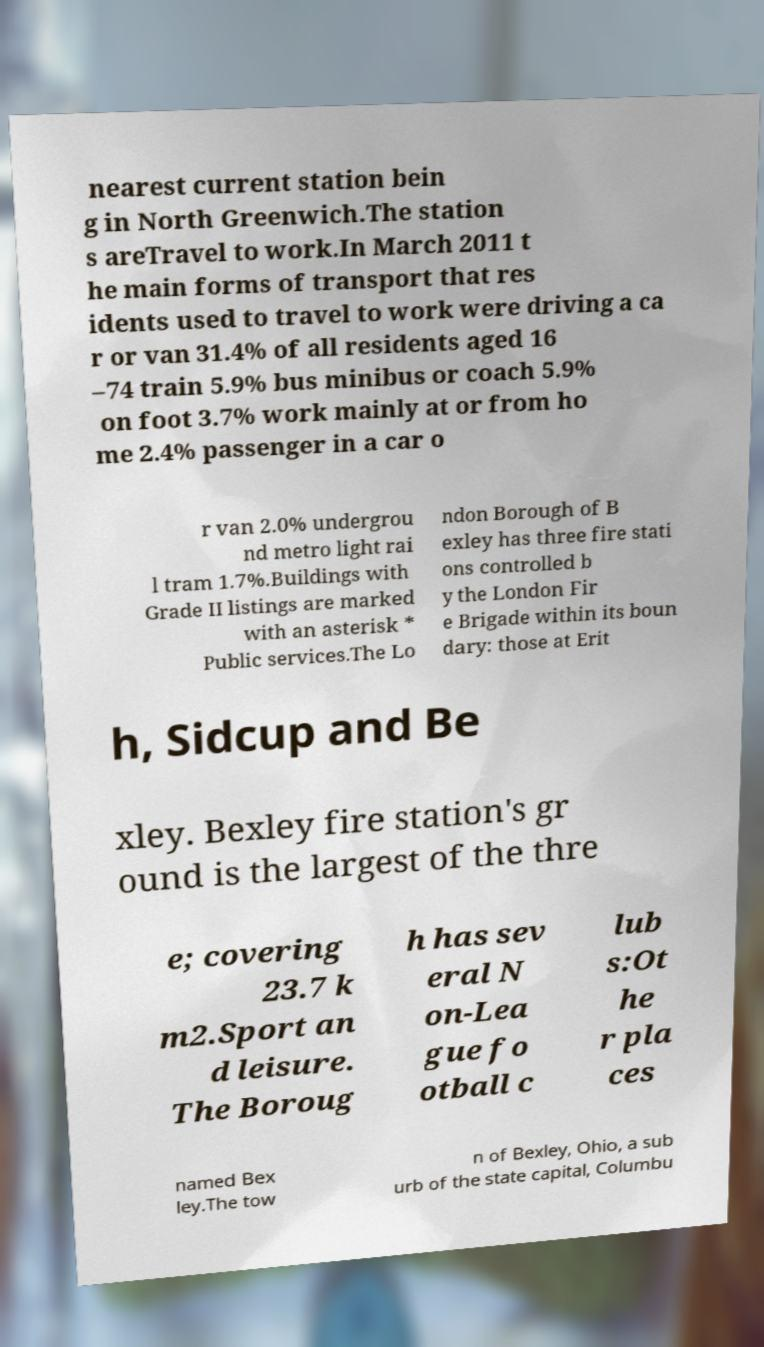Could you extract and type out the text from this image? nearest current station bein g in North Greenwich.The station s areTravel to work.In March 2011 t he main forms of transport that res idents used to travel to work were driving a ca r or van 31.4% of all residents aged 16 –74 train 5.9% bus minibus or coach 5.9% on foot 3.7% work mainly at or from ho me 2.4% passenger in a car o r van 2.0% undergrou nd metro light rai l tram 1.7%.Buildings with Grade II listings are marked with an asterisk * Public services.The Lo ndon Borough of B exley has three fire stati ons controlled b y the London Fir e Brigade within its boun dary: those at Erit h, Sidcup and Be xley. Bexley fire station's gr ound is the largest of the thre e; covering 23.7 k m2.Sport an d leisure. The Boroug h has sev eral N on-Lea gue fo otball c lub s:Ot he r pla ces named Bex ley.The tow n of Bexley, Ohio, a sub urb of the state capital, Columbu 